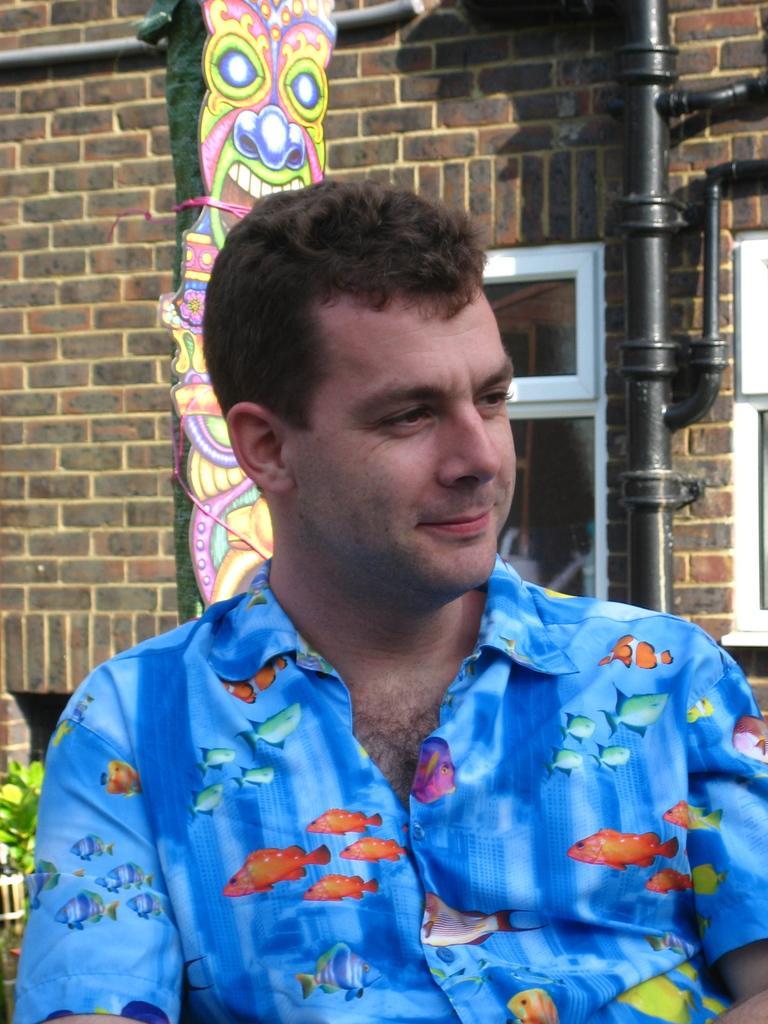Could you give a brief overview of what you see in this image? In this picture there is a person wearing blue dress and there is a building behind it. 